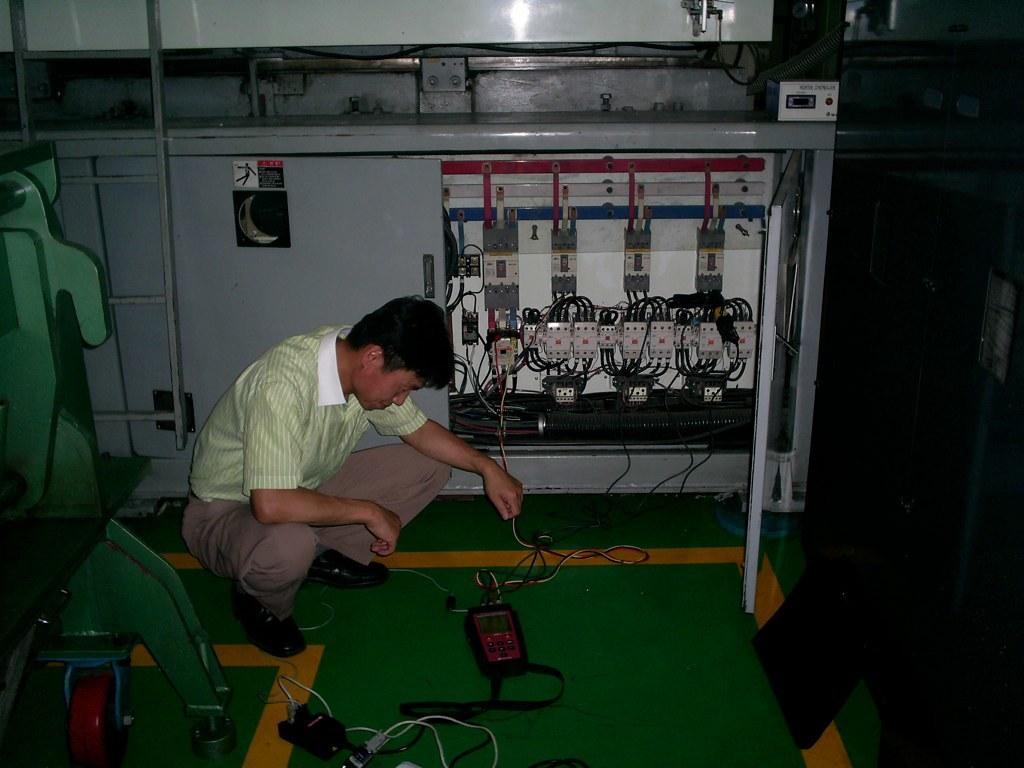In one or two sentences, can you explain what this image depicts? In the center of the image there is a person in squat position. In the background of the image there is a electronic device with wires. To the left side of the image there is a machine. 